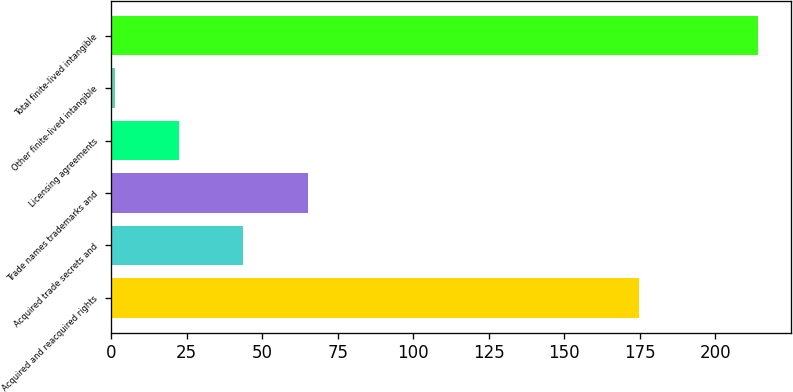<chart> <loc_0><loc_0><loc_500><loc_500><bar_chart><fcel>Acquired and reacquired rights<fcel>Acquired trade secrets and<fcel>Trade names trademarks and<fcel>Licensing agreements<fcel>Other finite-lived intangible<fcel>Total finite-lived intangible<nl><fcel>174.6<fcel>43.8<fcel>65.1<fcel>22.5<fcel>1.2<fcel>214.2<nl></chart> 